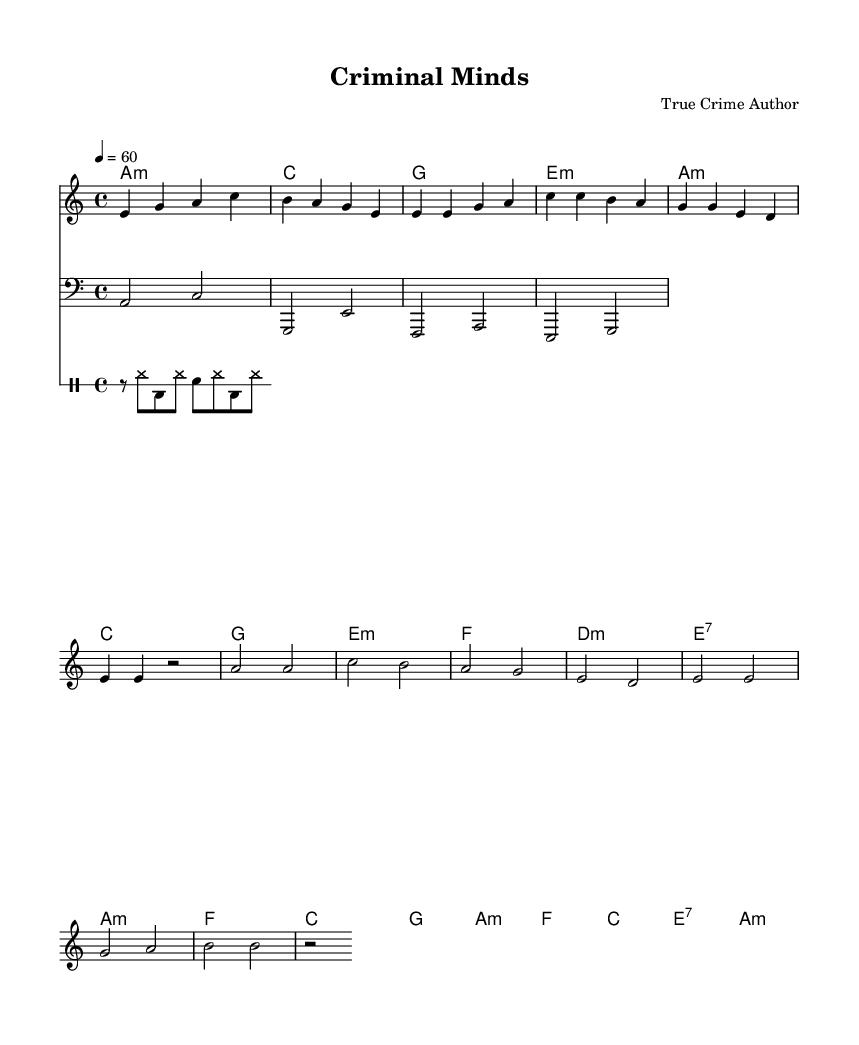What is the key signature of this music? The key signature is A minor, which has no sharps or flats indicated, and it is deduced from the presence of the A minor chord and the natural notes.
Answer: A minor What is the time signature of this music? The time signature is 4/4, which is evident from the division of the measures into four beats each, as indicated in the initial part of the score.
Answer: 4/4 What is the tempo marking of this music? The tempo marking is 60 beats per minute, displayed at the beginning of the score, indicating a slow pace suitable for a slow jam.
Answer: 60 How many measures are in the verse section? The verse consists of four measures, confirmed by counting the distinct groups of bars outlined within the score that correspond to the verse lyrics.
Answer: 4 What is the primary theme of the lyrics in this music? The primary theme is criminal minds and the psychological aspects associated with them, inferred from the lines discussing shadows in the mind and dark thoughts.
Answer: Criminal minds What is the chord played during the chorus? The chords played during the chorus include F, C, G, and A minor, as listed in the harmonies section that corresponds with the chorus lyrics.
Answer: F, C, G, A minor What instrumentation is used in this music? The instrumentation includes melody, bass, and drums, as indicated by the distinct parts labeled in the score, reflecting the standard arrangement for rhythm and blues.
Answer: Melody, bass, drums 